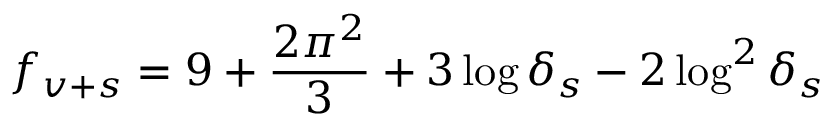<formula> <loc_0><loc_0><loc_500><loc_500>f _ { v + s } = 9 + \frac { 2 \pi ^ { 2 } } { 3 } + 3 \log \delta _ { s } - 2 \log ^ { 2 } \delta _ { s }</formula> 